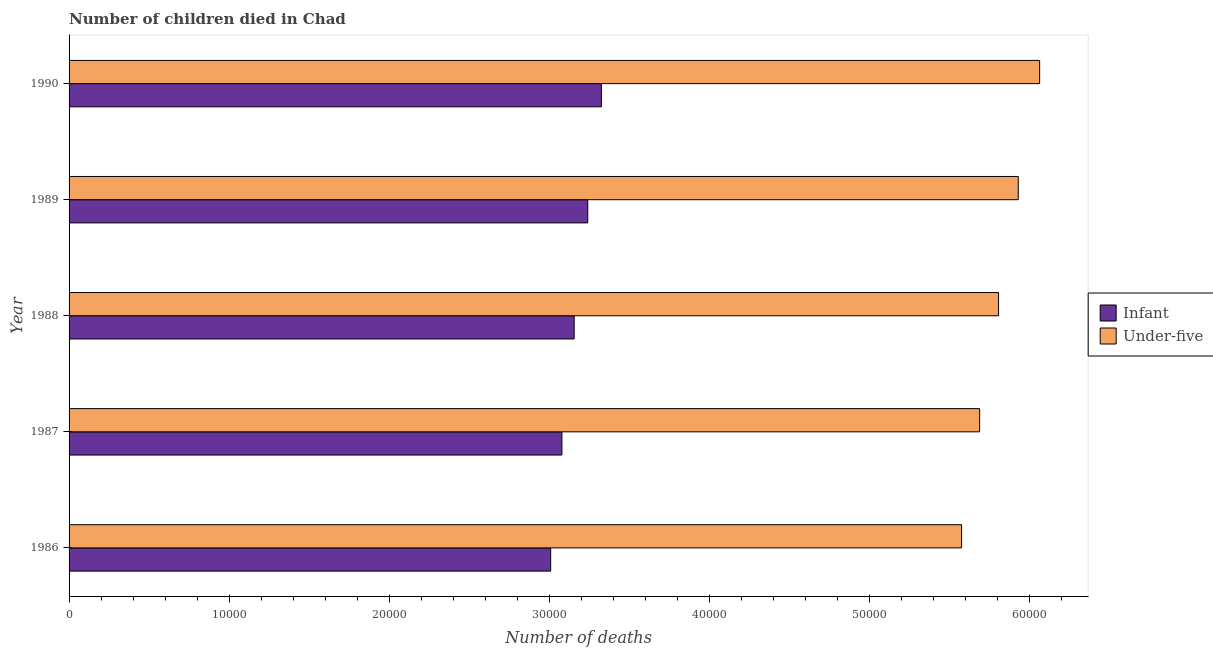Are the number of bars on each tick of the Y-axis equal?
Your response must be concise. Yes. How many bars are there on the 4th tick from the top?
Ensure brevity in your answer.  2. How many bars are there on the 2nd tick from the bottom?
Provide a succinct answer. 2. What is the number of under-five deaths in 1986?
Ensure brevity in your answer.  5.57e+04. Across all years, what is the maximum number of infant deaths?
Make the answer very short. 3.32e+04. Across all years, what is the minimum number of under-five deaths?
Give a very brief answer. 5.57e+04. In which year was the number of infant deaths maximum?
Your answer should be compact. 1990. In which year was the number of under-five deaths minimum?
Offer a very short reply. 1986. What is the total number of under-five deaths in the graph?
Your answer should be very brief. 2.91e+05. What is the difference between the number of infant deaths in 1986 and that in 1989?
Provide a short and direct response. -2317. What is the difference between the number of under-five deaths in 1990 and the number of infant deaths in 1989?
Your answer should be compact. 2.82e+04. What is the average number of infant deaths per year?
Ensure brevity in your answer.  3.16e+04. In the year 1990, what is the difference between the number of infant deaths and number of under-five deaths?
Provide a succinct answer. -2.74e+04. In how many years, is the number of infant deaths greater than 50000 ?
Offer a terse response. 0. What is the ratio of the number of under-five deaths in 1987 to that in 1990?
Offer a very short reply. 0.94. What is the difference between the highest and the second highest number of under-five deaths?
Offer a terse response. 1336. What is the difference between the highest and the lowest number of under-five deaths?
Offer a terse response. 4876. In how many years, is the number of infant deaths greater than the average number of infant deaths taken over all years?
Your answer should be very brief. 2. What does the 2nd bar from the top in 1986 represents?
Offer a terse response. Infant. What does the 2nd bar from the bottom in 1986 represents?
Keep it short and to the point. Under-five. What is the difference between two consecutive major ticks on the X-axis?
Your answer should be compact. 10000. Are the values on the major ticks of X-axis written in scientific E-notation?
Give a very brief answer. No. Does the graph contain grids?
Keep it short and to the point. No. Where does the legend appear in the graph?
Ensure brevity in your answer.  Center right. How many legend labels are there?
Ensure brevity in your answer.  2. How are the legend labels stacked?
Provide a short and direct response. Vertical. What is the title of the graph?
Provide a short and direct response. Number of children died in Chad. What is the label or title of the X-axis?
Offer a very short reply. Number of deaths. What is the label or title of the Y-axis?
Offer a very short reply. Year. What is the Number of deaths in Infant in 1986?
Keep it short and to the point. 3.01e+04. What is the Number of deaths in Under-five in 1986?
Offer a very short reply. 5.57e+04. What is the Number of deaths of Infant in 1987?
Provide a succinct answer. 3.08e+04. What is the Number of deaths of Under-five in 1987?
Your answer should be very brief. 5.69e+04. What is the Number of deaths of Infant in 1988?
Your answer should be very brief. 3.15e+04. What is the Number of deaths of Under-five in 1988?
Give a very brief answer. 5.81e+04. What is the Number of deaths of Infant in 1989?
Offer a very short reply. 3.24e+04. What is the Number of deaths in Under-five in 1989?
Make the answer very short. 5.93e+04. What is the Number of deaths in Infant in 1990?
Provide a short and direct response. 3.32e+04. What is the Number of deaths in Under-five in 1990?
Provide a short and direct response. 6.06e+04. Across all years, what is the maximum Number of deaths of Infant?
Your answer should be compact. 3.32e+04. Across all years, what is the maximum Number of deaths of Under-five?
Provide a short and direct response. 6.06e+04. Across all years, what is the minimum Number of deaths in Infant?
Your response must be concise. 3.01e+04. Across all years, what is the minimum Number of deaths in Under-five?
Provide a succinct answer. 5.57e+04. What is the total Number of deaths in Infant in the graph?
Provide a short and direct response. 1.58e+05. What is the total Number of deaths in Under-five in the graph?
Your answer should be very brief. 2.91e+05. What is the difference between the Number of deaths of Infant in 1986 and that in 1987?
Give a very brief answer. -703. What is the difference between the Number of deaths in Under-five in 1986 and that in 1987?
Keep it short and to the point. -1128. What is the difference between the Number of deaths in Infant in 1986 and that in 1988?
Provide a short and direct response. -1467. What is the difference between the Number of deaths of Under-five in 1986 and that in 1988?
Make the answer very short. -2311. What is the difference between the Number of deaths of Infant in 1986 and that in 1989?
Offer a very short reply. -2317. What is the difference between the Number of deaths of Under-five in 1986 and that in 1989?
Provide a short and direct response. -3540. What is the difference between the Number of deaths of Infant in 1986 and that in 1990?
Make the answer very short. -3169. What is the difference between the Number of deaths in Under-five in 1986 and that in 1990?
Keep it short and to the point. -4876. What is the difference between the Number of deaths of Infant in 1987 and that in 1988?
Provide a succinct answer. -764. What is the difference between the Number of deaths of Under-five in 1987 and that in 1988?
Keep it short and to the point. -1183. What is the difference between the Number of deaths of Infant in 1987 and that in 1989?
Ensure brevity in your answer.  -1614. What is the difference between the Number of deaths in Under-five in 1987 and that in 1989?
Provide a succinct answer. -2412. What is the difference between the Number of deaths of Infant in 1987 and that in 1990?
Offer a terse response. -2466. What is the difference between the Number of deaths of Under-five in 1987 and that in 1990?
Keep it short and to the point. -3748. What is the difference between the Number of deaths of Infant in 1988 and that in 1989?
Your response must be concise. -850. What is the difference between the Number of deaths in Under-five in 1988 and that in 1989?
Give a very brief answer. -1229. What is the difference between the Number of deaths in Infant in 1988 and that in 1990?
Make the answer very short. -1702. What is the difference between the Number of deaths in Under-five in 1988 and that in 1990?
Provide a short and direct response. -2565. What is the difference between the Number of deaths in Infant in 1989 and that in 1990?
Make the answer very short. -852. What is the difference between the Number of deaths in Under-five in 1989 and that in 1990?
Offer a terse response. -1336. What is the difference between the Number of deaths in Infant in 1986 and the Number of deaths in Under-five in 1987?
Ensure brevity in your answer.  -2.68e+04. What is the difference between the Number of deaths of Infant in 1986 and the Number of deaths of Under-five in 1988?
Offer a terse response. -2.80e+04. What is the difference between the Number of deaths of Infant in 1986 and the Number of deaths of Under-five in 1989?
Ensure brevity in your answer.  -2.92e+04. What is the difference between the Number of deaths in Infant in 1986 and the Number of deaths in Under-five in 1990?
Your answer should be very brief. -3.05e+04. What is the difference between the Number of deaths in Infant in 1987 and the Number of deaths in Under-five in 1988?
Offer a very short reply. -2.73e+04. What is the difference between the Number of deaths in Infant in 1987 and the Number of deaths in Under-five in 1989?
Ensure brevity in your answer.  -2.85e+04. What is the difference between the Number of deaths of Infant in 1987 and the Number of deaths of Under-five in 1990?
Offer a very short reply. -2.98e+04. What is the difference between the Number of deaths in Infant in 1988 and the Number of deaths in Under-five in 1989?
Make the answer very short. -2.77e+04. What is the difference between the Number of deaths in Infant in 1988 and the Number of deaths in Under-five in 1990?
Provide a short and direct response. -2.91e+04. What is the difference between the Number of deaths in Infant in 1989 and the Number of deaths in Under-five in 1990?
Ensure brevity in your answer.  -2.82e+04. What is the average Number of deaths in Infant per year?
Offer a terse response. 3.16e+04. What is the average Number of deaths of Under-five per year?
Ensure brevity in your answer.  5.81e+04. In the year 1986, what is the difference between the Number of deaths in Infant and Number of deaths in Under-five?
Make the answer very short. -2.57e+04. In the year 1987, what is the difference between the Number of deaths in Infant and Number of deaths in Under-five?
Provide a short and direct response. -2.61e+04. In the year 1988, what is the difference between the Number of deaths in Infant and Number of deaths in Under-five?
Ensure brevity in your answer.  -2.65e+04. In the year 1989, what is the difference between the Number of deaths in Infant and Number of deaths in Under-five?
Your answer should be very brief. -2.69e+04. In the year 1990, what is the difference between the Number of deaths in Infant and Number of deaths in Under-five?
Make the answer very short. -2.74e+04. What is the ratio of the Number of deaths of Infant in 1986 to that in 1987?
Give a very brief answer. 0.98. What is the ratio of the Number of deaths of Under-five in 1986 to that in 1987?
Keep it short and to the point. 0.98. What is the ratio of the Number of deaths in Infant in 1986 to that in 1988?
Offer a terse response. 0.95. What is the ratio of the Number of deaths in Under-five in 1986 to that in 1988?
Offer a very short reply. 0.96. What is the ratio of the Number of deaths in Infant in 1986 to that in 1989?
Provide a short and direct response. 0.93. What is the ratio of the Number of deaths in Under-five in 1986 to that in 1989?
Your response must be concise. 0.94. What is the ratio of the Number of deaths of Infant in 1986 to that in 1990?
Your answer should be very brief. 0.9. What is the ratio of the Number of deaths of Under-five in 1986 to that in 1990?
Keep it short and to the point. 0.92. What is the ratio of the Number of deaths in Infant in 1987 to that in 1988?
Provide a succinct answer. 0.98. What is the ratio of the Number of deaths in Under-five in 1987 to that in 1988?
Your answer should be very brief. 0.98. What is the ratio of the Number of deaths in Infant in 1987 to that in 1989?
Offer a terse response. 0.95. What is the ratio of the Number of deaths in Under-five in 1987 to that in 1989?
Your answer should be compact. 0.96. What is the ratio of the Number of deaths of Infant in 1987 to that in 1990?
Make the answer very short. 0.93. What is the ratio of the Number of deaths in Under-five in 1987 to that in 1990?
Your response must be concise. 0.94. What is the ratio of the Number of deaths in Infant in 1988 to that in 1989?
Offer a terse response. 0.97. What is the ratio of the Number of deaths of Under-five in 1988 to that in 1989?
Provide a short and direct response. 0.98. What is the ratio of the Number of deaths of Infant in 1988 to that in 1990?
Ensure brevity in your answer.  0.95. What is the ratio of the Number of deaths of Under-five in 1988 to that in 1990?
Make the answer very short. 0.96. What is the ratio of the Number of deaths in Infant in 1989 to that in 1990?
Provide a succinct answer. 0.97. What is the ratio of the Number of deaths of Under-five in 1989 to that in 1990?
Offer a very short reply. 0.98. What is the difference between the highest and the second highest Number of deaths of Infant?
Offer a terse response. 852. What is the difference between the highest and the second highest Number of deaths of Under-five?
Ensure brevity in your answer.  1336. What is the difference between the highest and the lowest Number of deaths of Infant?
Keep it short and to the point. 3169. What is the difference between the highest and the lowest Number of deaths of Under-five?
Your answer should be very brief. 4876. 